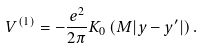Convert formula to latex. <formula><loc_0><loc_0><loc_500><loc_500>V ^ { \left ( 1 \right ) } = - \frac { e ^ { 2 } } { 2 \pi } K _ { 0 } \left ( { M | { y } - { y } ^ { \prime } | } \right ) .</formula> 